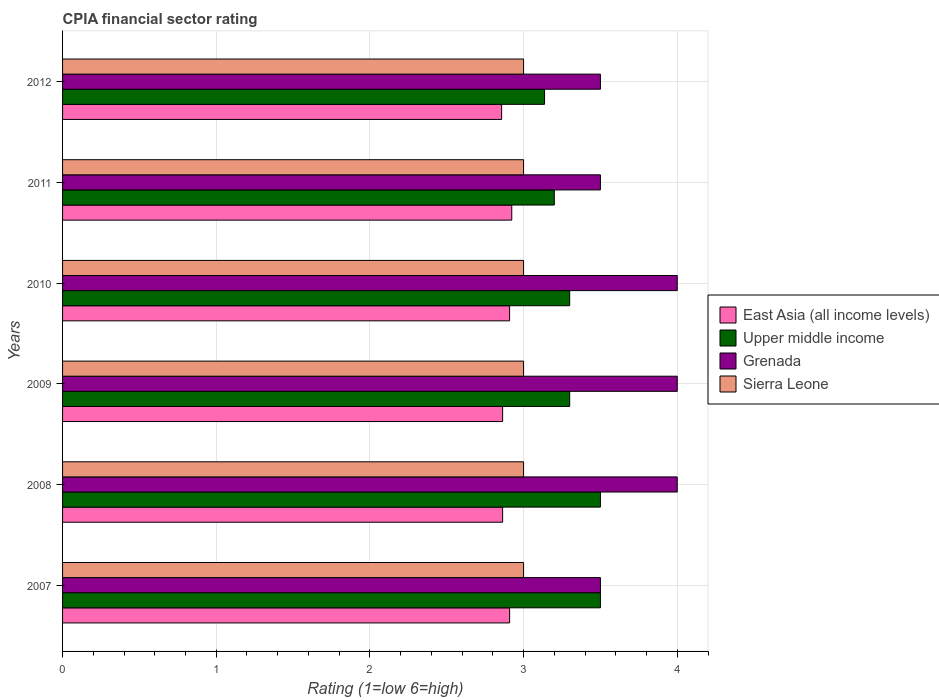How many different coloured bars are there?
Your answer should be compact. 4. Are the number of bars per tick equal to the number of legend labels?
Ensure brevity in your answer.  Yes. Are the number of bars on each tick of the Y-axis equal?
Your answer should be very brief. Yes. How many bars are there on the 3rd tick from the bottom?
Your answer should be very brief. 4. In how many cases, is the number of bars for a given year not equal to the number of legend labels?
Make the answer very short. 0. What is the CPIA rating in East Asia (all income levels) in 2009?
Ensure brevity in your answer.  2.86. Across all years, what is the maximum CPIA rating in East Asia (all income levels)?
Offer a terse response. 2.92. Across all years, what is the minimum CPIA rating in East Asia (all income levels)?
Give a very brief answer. 2.86. In which year was the CPIA rating in Sierra Leone minimum?
Keep it short and to the point. 2007. What is the total CPIA rating in Upper middle income in the graph?
Offer a terse response. 19.94. What is the difference between the CPIA rating in East Asia (all income levels) in 2010 and the CPIA rating in Upper middle income in 2011?
Your answer should be compact. -0.29. What is the average CPIA rating in East Asia (all income levels) per year?
Ensure brevity in your answer.  2.89. In the year 2008, what is the difference between the CPIA rating in East Asia (all income levels) and CPIA rating in Upper middle income?
Ensure brevity in your answer.  -0.64. Is the CPIA rating in East Asia (all income levels) in 2008 less than that in 2012?
Offer a very short reply. No. Is the difference between the CPIA rating in East Asia (all income levels) in 2008 and 2011 greater than the difference between the CPIA rating in Upper middle income in 2008 and 2011?
Offer a terse response. No. What is the difference between the highest and the lowest CPIA rating in Upper middle income?
Your response must be concise. 0.36. In how many years, is the CPIA rating in Sierra Leone greater than the average CPIA rating in Sierra Leone taken over all years?
Offer a very short reply. 0. Is the sum of the CPIA rating in East Asia (all income levels) in 2008 and 2009 greater than the maximum CPIA rating in Grenada across all years?
Your response must be concise. Yes. What does the 3rd bar from the top in 2010 represents?
Provide a succinct answer. Upper middle income. What does the 1st bar from the bottom in 2008 represents?
Offer a terse response. East Asia (all income levels). Is it the case that in every year, the sum of the CPIA rating in East Asia (all income levels) and CPIA rating in Sierra Leone is greater than the CPIA rating in Upper middle income?
Offer a very short reply. Yes. How many bars are there?
Your answer should be compact. 24. What is the difference between two consecutive major ticks on the X-axis?
Ensure brevity in your answer.  1. Are the values on the major ticks of X-axis written in scientific E-notation?
Make the answer very short. No. Does the graph contain grids?
Keep it short and to the point. Yes. How many legend labels are there?
Keep it short and to the point. 4. How are the legend labels stacked?
Your response must be concise. Vertical. What is the title of the graph?
Make the answer very short. CPIA financial sector rating. Does "Grenada" appear as one of the legend labels in the graph?
Keep it short and to the point. Yes. What is the label or title of the X-axis?
Make the answer very short. Rating (1=low 6=high). What is the Rating (1=low 6=high) in East Asia (all income levels) in 2007?
Your answer should be very brief. 2.91. What is the Rating (1=low 6=high) in Sierra Leone in 2007?
Provide a short and direct response. 3. What is the Rating (1=low 6=high) of East Asia (all income levels) in 2008?
Keep it short and to the point. 2.86. What is the Rating (1=low 6=high) of East Asia (all income levels) in 2009?
Your answer should be compact. 2.86. What is the Rating (1=low 6=high) of East Asia (all income levels) in 2010?
Offer a very short reply. 2.91. What is the Rating (1=low 6=high) of Grenada in 2010?
Make the answer very short. 4. What is the Rating (1=low 6=high) in Sierra Leone in 2010?
Offer a very short reply. 3. What is the Rating (1=low 6=high) of East Asia (all income levels) in 2011?
Your response must be concise. 2.92. What is the Rating (1=low 6=high) in Upper middle income in 2011?
Make the answer very short. 3.2. What is the Rating (1=low 6=high) in Grenada in 2011?
Your answer should be very brief. 3.5. What is the Rating (1=low 6=high) of Sierra Leone in 2011?
Provide a short and direct response. 3. What is the Rating (1=low 6=high) of East Asia (all income levels) in 2012?
Offer a very short reply. 2.86. What is the Rating (1=low 6=high) in Upper middle income in 2012?
Ensure brevity in your answer.  3.14. Across all years, what is the maximum Rating (1=low 6=high) in East Asia (all income levels)?
Provide a succinct answer. 2.92. Across all years, what is the maximum Rating (1=low 6=high) of Grenada?
Offer a very short reply. 4. Across all years, what is the maximum Rating (1=low 6=high) of Sierra Leone?
Provide a short and direct response. 3. Across all years, what is the minimum Rating (1=low 6=high) in East Asia (all income levels)?
Your answer should be compact. 2.86. Across all years, what is the minimum Rating (1=low 6=high) of Upper middle income?
Offer a terse response. 3.14. Across all years, what is the minimum Rating (1=low 6=high) in Grenada?
Give a very brief answer. 3.5. Across all years, what is the minimum Rating (1=low 6=high) of Sierra Leone?
Offer a terse response. 3. What is the total Rating (1=low 6=high) of East Asia (all income levels) in the graph?
Your answer should be very brief. 17.33. What is the total Rating (1=low 6=high) in Upper middle income in the graph?
Your answer should be compact. 19.94. What is the total Rating (1=low 6=high) in Sierra Leone in the graph?
Ensure brevity in your answer.  18. What is the difference between the Rating (1=low 6=high) in East Asia (all income levels) in 2007 and that in 2008?
Keep it short and to the point. 0.05. What is the difference between the Rating (1=low 6=high) in Sierra Leone in 2007 and that in 2008?
Offer a terse response. 0. What is the difference between the Rating (1=low 6=high) in East Asia (all income levels) in 2007 and that in 2009?
Your answer should be compact. 0.05. What is the difference between the Rating (1=low 6=high) in Grenada in 2007 and that in 2009?
Provide a succinct answer. -0.5. What is the difference between the Rating (1=low 6=high) of Sierra Leone in 2007 and that in 2009?
Offer a very short reply. 0. What is the difference between the Rating (1=low 6=high) in East Asia (all income levels) in 2007 and that in 2010?
Provide a short and direct response. 0. What is the difference between the Rating (1=low 6=high) of Sierra Leone in 2007 and that in 2010?
Your answer should be very brief. 0. What is the difference between the Rating (1=low 6=high) in East Asia (all income levels) in 2007 and that in 2011?
Ensure brevity in your answer.  -0.01. What is the difference between the Rating (1=low 6=high) of Upper middle income in 2007 and that in 2011?
Keep it short and to the point. 0.3. What is the difference between the Rating (1=low 6=high) of Grenada in 2007 and that in 2011?
Offer a terse response. 0. What is the difference between the Rating (1=low 6=high) in Sierra Leone in 2007 and that in 2011?
Your answer should be very brief. 0. What is the difference between the Rating (1=low 6=high) in East Asia (all income levels) in 2007 and that in 2012?
Your response must be concise. 0.05. What is the difference between the Rating (1=low 6=high) of Upper middle income in 2007 and that in 2012?
Your answer should be very brief. 0.36. What is the difference between the Rating (1=low 6=high) in East Asia (all income levels) in 2008 and that in 2009?
Offer a terse response. 0. What is the difference between the Rating (1=low 6=high) in East Asia (all income levels) in 2008 and that in 2010?
Your response must be concise. -0.05. What is the difference between the Rating (1=low 6=high) in Grenada in 2008 and that in 2010?
Give a very brief answer. 0. What is the difference between the Rating (1=low 6=high) in Sierra Leone in 2008 and that in 2010?
Provide a succinct answer. 0. What is the difference between the Rating (1=low 6=high) in East Asia (all income levels) in 2008 and that in 2011?
Offer a very short reply. -0.06. What is the difference between the Rating (1=low 6=high) of Upper middle income in 2008 and that in 2011?
Provide a succinct answer. 0.3. What is the difference between the Rating (1=low 6=high) in Sierra Leone in 2008 and that in 2011?
Offer a very short reply. 0. What is the difference between the Rating (1=low 6=high) in East Asia (all income levels) in 2008 and that in 2012?
Keep it short and to the point. 0.01. What is the difference between the Rating (1=low 6=high) in Upper middle income in 2008 and that in 2012?
Your response must be concise. 0.36. What is the difference between the Rating (1=low 6=high) of Sierra Leone in 2008 and that in 2012?
Provide a short and direct response. 0. What is the difference between the Rating (1=low 6=high) in East Asia (all income levels) in 2009 and that in 2010?
Your answer should be compact. -0.05. What is the difference between the Rating (1=low 6=high) in Upper middle income in 2009 and that in 2010?
Keep it short and to the point. 0. What is the difference between the Rating (1=low 6=high) of Grenada in 2009 and that in 2010?
Your response must be concise. 0. What is the difference between the Rating (1=low 6=high) in Sierra Leone in 2009 and that in 2010?
Make the answer very short. 0. What is the difference between the Rating (1=low 6=high) in East Asia (all income levels) in 2009 and that in 2011?
Provide a succinct answer. -0.06. What is the difference between the Rating (1=low 6=high) of Sierra Leone in 2009 and that in 2011?
Make the answer very short. 0. What is the difference between the Rating (1=low 6=high) in East Asia (all income levels) in 2009 and that in 2012?
Offer a very short reply. 0.01. What is the difference between the Rating (1=low 6=high) of Upper middle income in 2009 and that in 2012?
Ensure brevity in your answer.  0.16. What is the difference between the Rating (1=low 6=high) in Sierra Leone in 2009 and that in 2012?
Give a very brief answer. 0. What is the difference between the Rating (1=low 6=high) of East Asia (all income levels) in 2010 and that in 2011?
Your answer should be very brief. -0.01. What is the difference between the Rating (1=low 6=high) in Upper middle income in 2010 and that in 2011?
Your answer should be very brief. 0.1. What is the difference between the Rating (1=low 6=high) in Sierra Leone in 2010 and that in 2011?
Your response must be concise. 0. What is the difference between the Rating (1=low 6=high) of East Asia (all income levels) in 2010 and that in 2012?
Your response must be concise. 0.05. What is the difference between the Rating (1=low 6=high) in Upper middle income in 2010 and that in 2012?
Your response must be concise. 0.16. What is the difference between the Rating (1=low 6=high) of Grenada in 2010 and that in 2012?
Your response must be concise. 0.5. What is the difference between the Rating (1=low 6=high) in East Asia (all income levels) in 2011 and that in 2012?
Your response must be concise. 0.07. What is the difference between the Rating (1=low 6=high) of Upper middle income in 2011 and that in 2012?
Your response must be concise. 0.06. What is the difference between the Rating (1=low 6=high) of East Asia (all income levels) in 2007 and the Rating (1=low 6=high) of Upper middle income in 2008?
Your response must be concise. -0.59. What is the difference between the Rating (1=low 6=high) of East Asia (all income levels) in 2007 and the Rating (1=low 6=high) of Grenada in 2008?
Provide a short and direct response. -1.09. What is the difference between the Rating (1=low 6=high) in East Asia (all income levels) in 2007 and the Rating (1=low 6=high) in Sierra Leone in 2008?
Offer a terse response. -0.09. What is the difference between the Rating (1=low 6=high) in Upper middle income in 2007 and the Rating (1=low 6=high) in Grenada in 2008?
Keep it short and to the point. -0.5. What is the difference between the Rating (1=low 6=high) in Grenada in 2007 and the Rating (1=low 6=high) in Sierra Leone in 2008?
Your response must be concise. 0.5. What is the difference between the Rating (1=low 6=high) of East Asia (all income levels) in 2007 and the Rating (1=low 6=high) of Upper middle income in 2009?
Provide a short and direct response. -0.39. What is the difference between the Rating (1=low 6=high) in East Asia (all income levels) in 2007 and the Rating (1=low 6=high) in Grenada in 2009?
Your answer should be very brief. -1.09. What is the difference between the Rating (1=low 6=high) of East Asia (all income levels) in 2007 and the Rating (1=low 6=high) of Sierra Leone in 2009?
Provide a short and direct response. -0.09. What is the difference between the Rating (1=low 6=high) of Upper middle income in 2007 and the Rating (1=low 6=high) of Grenada in 2009?
Your answer should be very brief. -0.5. What is the difference between the Rating (1=low 6=high) of Upper middle income in 2007 and the Rating (1=low 6=high) of Sierra Leone in 2009?
Give a very brief answer. 0.5. What is the difference between the Rating (1=low 6=high) in East Asia (all income levels) in 2007 and the Rating (1=low 6=high) in Upper middle income in 2010?
Give a very brief answer. -0.39. What is the difference between the Rating (1=low 6=high) of East Asia (all income levels) in 2007 and the Rating (1=low 6=high) of Grenada in 2010?
Your answer should be very brief. -1.09. What is the difference between the Rating (1=low 6=high) of East Asia (all income levels) in 2007 and the Rating (1=low 6=high) of Sierra Leone in 2010?
Your answer should be compact. -0.09. What is the difference between the Rating (1=low 6=high) of Upper middle income in 2007 and the Rating (1=low 6=high) of Grenada in 2010?
Keep it short and to the point. -0.5. What is the difference between the Rating (1=low 6=high) in East Asia (all income levels) in 2007 and the Rating (1=low 6=high) in Upper middle income in 2011?
Keep it short and to the point. -0.29. What is the difference between the Rating (1=low 6=high) of East Asia (all income levels) in 2007 and the Rating (1=low 6=high) of Grenada in 2011?
Keep it short and to the point. -0.59. What is the difference between the Rating (1=low 6=high) in East Asia (all income levels) in 2007 and the Rating (1=low 6=high) in Sierra Leone in 2011?
Make the answer very short. -0.09. What is the difference between the Rating (1=low 6=high) of Upper middle income in 2007 and the Rating (1=low 6=high) of Grenada in 2011?
Ensure brevity in your answer.  0. What is the difference between the Rating (1=low 6=high) of Grenada in 2007 and the Rating (1=low 6=high) of Sierra Leone in 2011?
Ensure brevity in your answer.  0.5. What is the difference between the Rating (1=low 6=high) in East Asia (all income levels) in 2007 and the Rating (1=low 6=high) in Upper middle income in 2012?
Keep it short and to the point. -0.23. What is the difference between the Rating (1=low 6=high) in East Asia (all income levels) in 2007 and the Rating (1=low 6=high) in Grenada in 2012?
Provide a short and direct response. -0.59. What is the difference between the Rating (1=low 6=high) in East Asia (all income levels) in 2007 and the Rating (1=low 6=high) in Sierra Leone in 2012?
Your answer should be very brief. -0.09. What is the difference between the Rating (1=low 6=high) of Grenada in 2007 and the Rating (1=low 6=high) of Sierra Leone in 2012?
Give a very brief answer. 0.5. What is the difference between the Rating (1=low 6=high) in East Asia (all income levels) in 2008 and the Rating (1=low 6=high) in Upper middle income in 2009?
Ensure brevity in your answer.  -0.44. What is the difference between the Rating (1=low 6=high) of East Asia (all income levels) in 2008 and the Rating (1=low 6=high) of Grenada in 2009?
Offer a very short reply. -1.14. What is the difference between the Rating (1=low 6=high) in East Asia (all income levels) in 2008 and the Rating (1=low 6=high) in Sierra Leone in 2009?
Your answer should be very brief. -0.14. What is the difference between the Rating (1=low 6=high) in Upper middle income in 2008 and the Rating (1=low 6=high) in Grenada in 2009?
Keep it short and to the point. -0.5. What is the difference between the Rating (1=low 6=high) in Upper middle income in 2008 and the Rating (1=low 6=high) in Sierra Leone in 2009?
Provide a succinct answer. 0.5. What is the difference between the Rating (1=low 6=high) of East Asia (all income levels) in 2008 and the Rating (1=low 6=high) of Upper middle income in 2010?
Ensure brevity in your answer.  -0.44. What is the difference between the Rating (1=low 6=high) in East Asia (all income levels) in 2008 and the Rating (1=low 6=high) in Grenada in 2010?
Provide a succinct answer. -1.14. What is the difference between the Rating (1=low 6=high) in East Asia (all income levels) in 2008 and the Rating (1=low 6=high) in Sierra Leone in 2010?
Give a very brief answer. -0.14. What is the difference between the Rating (1=low 6=high) in Upper middle income in 2008 and the Rating (1=low 6=high) in Sierra Leone in 2010?
Ensure brevity in your answer.  0.5. What is the difference between the Rating (1=low 6=high) in East Asia (all income levels) in 2008 and the Rating (1=low 6=high) in Upper middle income in 2011?
Give a very brief answer. -0.34. What is the difference between the Rating (1=low 6=high) in East Asia (all income levels) in 2008 and the Rating (1=low 6=high) in Grenada in 2011?
Make the answer very short. -0.64. What is the difference between the Rating (1=low 6=high) of East Asia (all income levels) in 2008 and the Rating (1=low 6=high) of Sierra Leone in 2011?
Make the answer very short. -0.14. What is the difference between the Rating (1=low 6=high) of Upper middle income in 2008 and the Rating (1=low 6=high) of Sierra Leone in 2011?
Offer a very short reply. 0.5. What is the difference between the Rating (1=low 6=high) in East Asia (all income levels) in 2008 and the Rating (1=low 6=high) in Upper middle income in 2012?
Offer a very short reply. -0.27. What is the difference between the Rating (1=low 6=high) in East Asia (all income levels) in 2008 and the Rating (1=low 6=high) in Grenada in 2012?
Offer a very short reply. -0.64. What is the difference between the Rating (1=low 6=high) in East Asia (all income levels) in 2008 and the Rating (1=low 6=high) in Sierra Leone in 2012?
Provide a succinct answer. -0.14. What is the difference between the Rating (1=low 6=high) in Upper middle income in 2008 and the Rating (1=low 6=high) in Grenada in 2012?
Give a very brief answer. 0. What is the difference between the Rating (1=low 6=high) of East Asia (all income levels) in 2009 and the Rating (1=low 6=high) of Upper middle income in 2010?
Offer a terse response. -0.44. What is the difference between the Rating (1=low 6=high) of East Asia (all income levels) in 2009 and the Rating (1=low 6=high) of Grenada in 2010?
Your answer should be very brief. -1.14. What is the difference between the Rating (1=low 6=high) in East Asia (all income levels) in 2009 and the Rating (1=low 6=high) in Sierra Leone in 2010?
Make the answer very short. -0.14. What is the difference between the Rating (1=low 6=high) of Grenada in 2009 and the Rating (1=low 6=high) of Sierra Leone in 2010?
Your response must be concise. 1. What is the difference between the Rating (1=low 6=high) in East Asia (all income levels) in 2009 and the Rating (1=low 6=high) in Upper middle income in 2011?
Give a very brief answer. -0.34. What is the difference between the Rating (1=low 6=high) in East Asia (all income levels) in 2009 and the Rating (1=low 6=high) in Grenada in 2011?
Offer a very short reply. -0.64. What is the difference between the Rating (1=low 6=high) in East Asia (all income levels) in 2009 and the Rating (1=low 6=high) in Sierra Leone in 2011?
Your answer should be compact. -0.14. What is the difference between the Rating (1=low 6=high) of Upper middle income in 2009 and the Rating (1=low 6=high) of Sierra Leone in 2011?
Your response must be concise. 0.3. What is the difference between the Rating (1=low 6=high) in East Asia (all income levels) in 2009 and the Rating (1=low 6=high) in Upper middle income in 2012?
Your answer should be very brief. -0.27. What is the difference between the Rating (1=low 6=high) in East Asia (all income levels) in 2009 and the Rating (1=low 6=high) in Grenada in 2012?
Your answer should be compact. -0.64. What is the difference between the Rating (1=low 6=high) of East Asia (all income levels) in 2009 and the Rating (1=low 6=high) of Sierra Leone in 2012?
Your answer should be compact. -0.14. What is the difference between the Rating (1=low 6=high) of East Asia (all income levels) in 2010 and the Rating (1=low 6=high) of Upper middle income in 2011?
Make the answer very short. -0.29. What is the difference between the Rating (1=low 6=high) of East Asia (all income levels) in 2010 and the Rating (1=low 6=high) of Grenada in 2011?
Keep it short and to the point. -0.59. What is the difference between the Rating (1=low 6=high) in East Asia (all income levels) in 2010 and the Rating (1=low 6=high) in Sierra Leone in 2011?
Offer a very short reply. -0.09. What is the difference between the Rating (1=low 6=high) in Grenada in 2010 and the Rating (1=low 6=high) in Sierra Leone in 2011?
Your answer should be compact. 1. What is the difference between the Rating (1=low 6=high) in East Asia (all income levels) in 2010 and the Rating (1=low 6=high) in Upper middle income in 2012?
Ensure brevity in your answer.  -0.23. What is the difference between the Rating (1=low 6=high) of East Asia (all income levels) in 2010 and the Rating (1=low 6=high) of Grenada in 2012?
Provide a short and direct response. -0.59. What is the difference between the Rating (1=low 6=high) in East Asia (all income levels) in 2010 and the Rating (1=low 6=high) in Sierra Leone in 2012?
Provide a succinct answer. -0.09. What is the difference between the Rating (1=low 6=high) in Upper middle income in 2010 and the Rating (1=low 6=high) in Grenada in 2012?
Give a very brief answer. -0.2. What is the difference between the Rating (1=low 6=high) of Grenada in 2010 and the Rating (1=low 6=high) of Sierra Leone in 2012?
Your answer should be very brief. 1. What is the difference between the Rating (1=low 6=high) in East Asia (all income levels) in 2011 and the Rating (1=low 6=high) in Upper middle income in 2012?
Give a very brief answer. -0.21. What is the difference between the Rating (1=low 6=high) in East Asia (all income levels) in 2011 and the Rating (1=low 6=high) in Grenada in 2012?
Make the answer very short. -0.58. What is the difference between the Rating (1=low 6=high) in East Asia (all income levels) in 2011 and the Rating (1=low 6=high) in Sierra Leone in 2012?
Offer a terse response. -0.08. What is the difference between the Rating (1=low 6=high) of Upper middle income in 2011 and the Rating (1=low 6=high) of Sierra Leone in 2012?
Your response must be concise. 0.2. What is the average Rating (1=low 6=high) in East Asia (all income levels) per year?
Ensure brevity in your answer.  2.89. What is the average Rating (1=low 6=high) in Upper middle income per year?
Offer a terse response. 3.32. What is the average Rating (1=low 6=high) of Grenada per year?
Provide a short and direct response. 3.75. What is the average Rating (1=low 6=high) of Sierra Leone per year?
Provide a succinct answer. 3. In the year 2007, what is the difference between the Rating (1=low 6=high) in East Asia (all income levels) and Rating (1=low 6=high) in Upper middle income?
Offer a terse response. -0.59. In the year 2007, what is the difference between the Rating (1=low 6=high) in East Asia (all income levels) and Rating (1=low 6=high) in Grenada?
Your answer should be compact. -0.59. In the year 2007, what is the difference between the Rating (1=low 6=high) of East Asia (all income levels) and Rating (1=low 6=high) of Sierra Leone?
Offer a terse response. -0.09. In the year 2007, what is the difference between the Rating (1=low 6=high) of Upper middle income and Rating (1=low 6=high) of Grenada?
Make the answer very short. 0. In the year 2008, what is the difference between the Rating (1=low 6=high) of East Asia (all income levels) and Rating (1=low 6=high) of Upper middle income?
Provide a short and direct response. -0.64. In the year 2008, what is the difference between the Rating (1=low 6=high) of East Asia (all income levels) and Rating (1=low 6=high) of Grenada?
Your answer should be very brief. -1.14. In the year 2008, what is the difference between the Rating (1=low 6=high) in East Asia (all income levels) and Rating (1=low 6=high) in Sierra Leone?
Ensure brevity in your answer.  -0.14. In the year 2008, what is the difference between the Rating (1=low 6=high) in Upper middle income and Rating (1=low 6=high) in Grenada?
Keep it short and to the point. -0.5. In the year 2008, what is the difference between the Rating (1=low 6=high) of Grenada and Rating (1=low 6=high) of Sierra Leone?
Your response must be concise. 1. In the year 2009, what is the difference between the Rating (1=low 6=high) in East Asia (all income levels) and Rating (1=low 6=high) in Upper middle income?
Your answer should be compact. -0.44. In the year 2009, what is the difference between the Rating (1=low 6=high) of East Asia (all income levels) and Rating (1=low 6=high) of Grenada?
Ensure brevity in your answer.  -1.14. In the year 2009, what is the difference between the Rating (1=low 6=high) of East Asia (all income levels) and Rating (1=low 6=high) of Sierra Leone?
Your answer should be very brief. -0.14. In the year 2009, what is the difference between the Rating (1=low 6=high) of Upper middle income and Rating (1=low 6=high) of Sierra Leone?
Offer a terse response. 0.3. In the year 2010, what is the difference between the Rating (1=low 6=high) of East Asia (all income levels) and Rating (1=low 6=high) of Upper middle income?
Keep it short and to the point. -0.39. In the year 2010, what is the difference between the Rating (1=low 6=high) in East Asia (all income levels) and Rating (1=low 6=high) in Grenada?
Offer a very short reply. -1.09. In the year 2010, what is the difference between the Rating (1=low 6=high) of East Asia (all income levels) and Rating (1=low 6=high) of Sierra Leone?
Give a very brief answer. -0.09. In the year 2010, what is the difference between the Rating (1=low 6=high) in Upper middle income and Rating (1=low 6=high) in Sierra Leone?
Your answer should be very brief. 0.3. In the year 2011, what is the difference between the Rating (1=low 6=high) of East Asia (all income levels) and Rating (1=low 6=high) of Upper middle income?
Provide a short and direct response. -0.28. In the year 2011, what is the difference between the Rating (1=low 6=high) of East Asia (all income levels) and Rating (1=low 6=high) of Grenada?
Make the answer very short. -0.58. In the year 2011, what is the difference between the Rating (1=low 6=high) of East Asia (all income levels) and Rating (1=low 6=high) of Sierra Leone?
Make the answer very short. -0.08. In the year 2011, what is the difference between the Rating (1=low 6=high) in Upper middle income and Rating (1=low 6=high) in Grenada?
Provide a succinct answer. -0.3. In the year 2011, what is the difference between the Rating (1=low 6=high) of Upper middle income and Rating (1=low 6=high) of Sierra Leone?
Ensure brevity in your answer.  0.2. In the year 2012, what is the difference between the Rating (1=low 6=high) in East Asia (all income levels) and Rating (1=low 6=high) in Upper middle income?
Give a very brief answer. -0.28. In the year 2012, what is the difference between the Rating (1=low 6=high) in East Asia (all income levels) and Rating (1=low 6=high) in Grenada?
Provide a short and direct response. -0.64. In the year 2012, what is the difference between the Rating (1=low 6=high) of East Asia (all income levels) and Rating (1=low 6=high) of Sierra Leone?
Offer a terse response. -0.14. In the year 2012, what is the difference between the Rating (1=low 6=high) in Upper middle income and Rating (1=low 6=high) in Grenada?
Ensure brevity in your answer.  -0.36. In the year 2012, what is the difference between the Rating (1=low 6=high) of Upper middle income and Rating (1=low 6=high) of Sierra Leone?
Offer a very short reply. 0.14. In the year 2012, what is the difference between the Rating (1=low 6=high) in Grenada and Rating (1=low 6=high) in Sierra Leone?
Offer a terse response. 0.5. What is the ratio of the Rating (1=low 6=high) of East Asia (all income levels) in 2007 to that in 2008?
Offer a terse response. 1.02. What is the ratio of the Rating (1=low 6=high) of Grenada in 2007 to that in 2008?
Your response must be concise. 0.88. What is the ratio of the Rating (1=low 6=high) in East Asia (all income levels) in 2007 to that in 2009?
Give a very brief answer. 1.02. What is the ratio of the Rating (1=low 6=high) in Upper middle income in 2007 to that in 2009?
Ensure brevity in your answer.  1.06. What is the ratio of the Rating (1=low 6=high) of East Asia (all income levels) in 2007 to that in 2010?
Your answer should be very brief. 1. What is the ratio of the Rating (1=low 6=high) of Upper middle income in 2007 to that in 2010?
Offer a terse response. 1.06. What is the ratio of the Rating (1=low 6=high) of Grenada in 2007 to that in 2010?
Provide a short and direct response. 0.88. What is the ratio of the Rating (1=low 6=high) in East Asia (all income levels) in 2007 to that in 2011?
Make the answer very short. 1. What is the ratio of the Rating (1=low 6=high) of Upper middle income in 2007 to that in 2011?
Offer a very short reply. 1.09. What is the ratio of the Rating (1=low 6=high) in Grenada in 2007 to that in 2011?
Provide a short and direct response. 1. What is the ratio of the Rating (1=low 6=high) in Sierra Leone in 2007 to that in 2011?
Give a very brief answer. 1. What is the ratio of the Rating (1=low 6=high) of East Asia (all income levels) in 2007 to that in 2012?
Offer a very short reply. 1.02. What is the ratio of the Rating (1=low 6=high) in Upper middle income in 2007 to that in 2012?
Offer a very short reply. 1.12. What is the ratio of the Rating (1=low 6=high) in Grenada in 2007 to that in 2012?
Make the answer very short. 1. What is the ratio of the Rating (1=low 6=high) of Sierra Leone in 2007 to that in 2012?
Provide a succinct answer. 1. What is the ratio of the Rating (1=low 6=high) of Upper middle income in 2008 to that in 2009?
Make the answer very short. 1.06. What is the ratio of the Rating (1=low 6=high) in Grenada in 2008 to that in 2009?
Offer a terse response. 1. What is the ratio of the Rating (1=low 6=high) in East Asia (all income levels) in 2008 to that in 2010?
Make the answer very short. 0.98. What is the ratio of the Rating (1=low 6=high) of Upper middle income in 2008 to that in 2010?
Your answer should be compact. 1.06. What is the ratio of the Rating (1=low 6=high) of Grenada in 2008 to that in 2010?
Make the answer very short. 1. What is the ratio of the Rating (1=low 6=high) of Sierra Leone in 2008 to that in 2010?
Provide a succinct answer. 1. What is the ratio of the Rating (1=low 6=high) of East Asia (all income levels) in 2008 to that in 2011?
Give a very brief answer. 0.98. What is the ratio of the Rating (1=low 6=high) of Upper middle income in 2008 to that in 2011?
Make the answer very short. 1.09. What is the ratio of the Rating (1=low 6=high) of East Asia (all income levels) in 2008 to that in 2012?
Ensure brevity in your answer.  1. What is the ratio of the Rating (1=low 6=high) in Upper middle income in 2008 to that in 2012?
Make the answer very short. 1.12. What is the ratio of the Rating (1=low 6=high) in East Asia (all income levels) in 2009 to that in 2010?
Offer a terse response. 0.98. What is the ratio of the Rating (1=low 6=high) of Sierra Leone in 2009 to that in 2010?
Your response must be concise. 1. What is the ratio of the Rating (1=low 6=high) of East Asia (all income levels) in 2009 to that in 2011?
Provide a succinct answer. 0.98. What is the ratio of the Rating (1=low 6=high) of Upper middle income in 2009 to that in 2011?
Provide a succinct answer. 1.03. What is the ratio of the Rating (1=low 6=high) of Grenada in 2009 to that in 2011?
Give a very brief answer. 1.14. What is the ratio of the Rating (1=low 6=high) in East Asia (all income levels) in 2009 to that in 2012?
Your response must be concise. 1. What is the ratio of the Rating (1=low 6=high) in Upper middle income in 2009 to that in 2012?
Your response must be concise. 1.05. What is the ratio of the Rating (1=low 6=high) in Sierra Leone in 2009 to that in 2012?
Your response must be concise. 1. What is the ratio of the Rating (1=low 6=high) of East Asia (all income levels) in 2010 to that in 2011?
Give a very brief answer. 1. What is the ratio of the Rating (1=low 6=high) of Upper middle income in 2010 to that in 2011?
Offer a terse response. 1.03. What is the ratio of the Rating (1=low 6=high) in Grenada in 2010 to that in 2011?
Offer a terse response. 1.14. What is the ratio of the Rating (1=low 6=high) of Sierra Leone in 2010 to that in 2011?
Give a very brief answer. 1. What is the ratio of the Rating (1=low 6=high) of East Asia (all income levels) in 2010 to that in 2012?
Give a very brief answer. 1.02. What is the ratio of the Rating (1=low 6=high) in Upper middle income in 2010 to that in 2012?
Your response must be concise. 1.05. What is the ratio of the Rating (1=low 6=high) in Grenada in 2010 to that in 2012?
Keep it short and to the point. 1.14. What is the ratio of the Rating (1=low 6=high) of East Asia (all income levels) in 2011 to that in 2012?
Offer a very short reply. 1.02. What is the ratio of the Rating (1=low 6=high) in Upper middle income in 2011 to that in 2012?
Provide a short and direct response. 1.02. What is the difference between the highest and the second highest Rating (1=low 6=high) in East Asia (all income levels)?
Provide a short and direct response. 0.01. What is the difference between the highest and the second highest Rating (1=low 6=high) in Upper middle income?
Make the answer very short. 0. What is the difference between the highest and the second highest Rating (1=low 6=high) in Grenada?
Your answer should be very brief. 0. What is the difference between the highest and the second highest Rating (1=low 6=high) of Sierra Leone?
Provide a short and direct response. 0. What is the difference between the highest and the lowest Rating (1=low 6=high) of East Asia (all income levels)?
Give a very brief answer. 0.07. What is the difference between the highest and the lowest Rating (1=low 6=high) in Upper middle income?
Ensure brevity in your answer.  0.36. What is the difference between the highest and the lowest Rating (1=low 6=high) in Grenada?
Make the answer very short. 0.5. What is the difference between the highest and the lowest Rating (1=low 6=high) in Sierra Leone?
Offer a terse response. 0. 